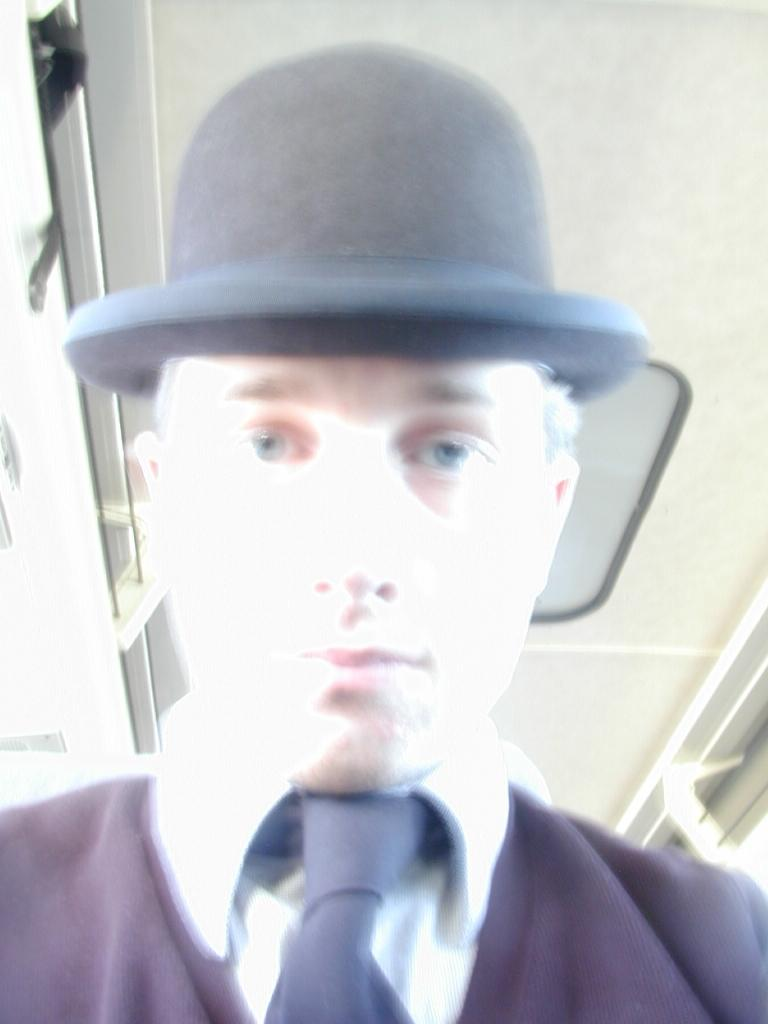What is the main subject of the image? There is a man in the image. What is the man wearing on his upper body? The man is wearing a white shirt. What accessories is the man wearing? The man is wearing a black tie and a black hat. How would you describe the quality of the image? The image is slightly blurry. How many pies are on the table next to the man in the image? There is no table or pies present in the image; it only features a man wearing a white shirt, black tie, and black hat. 